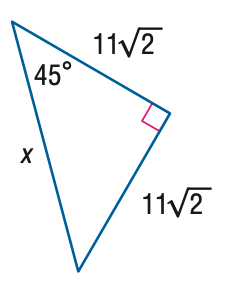Question: Find x.
Choices:
A. 11
B. 22
C. 22 \sqrt { 2 }
D. 44
Answer with the letter. Answer: B 